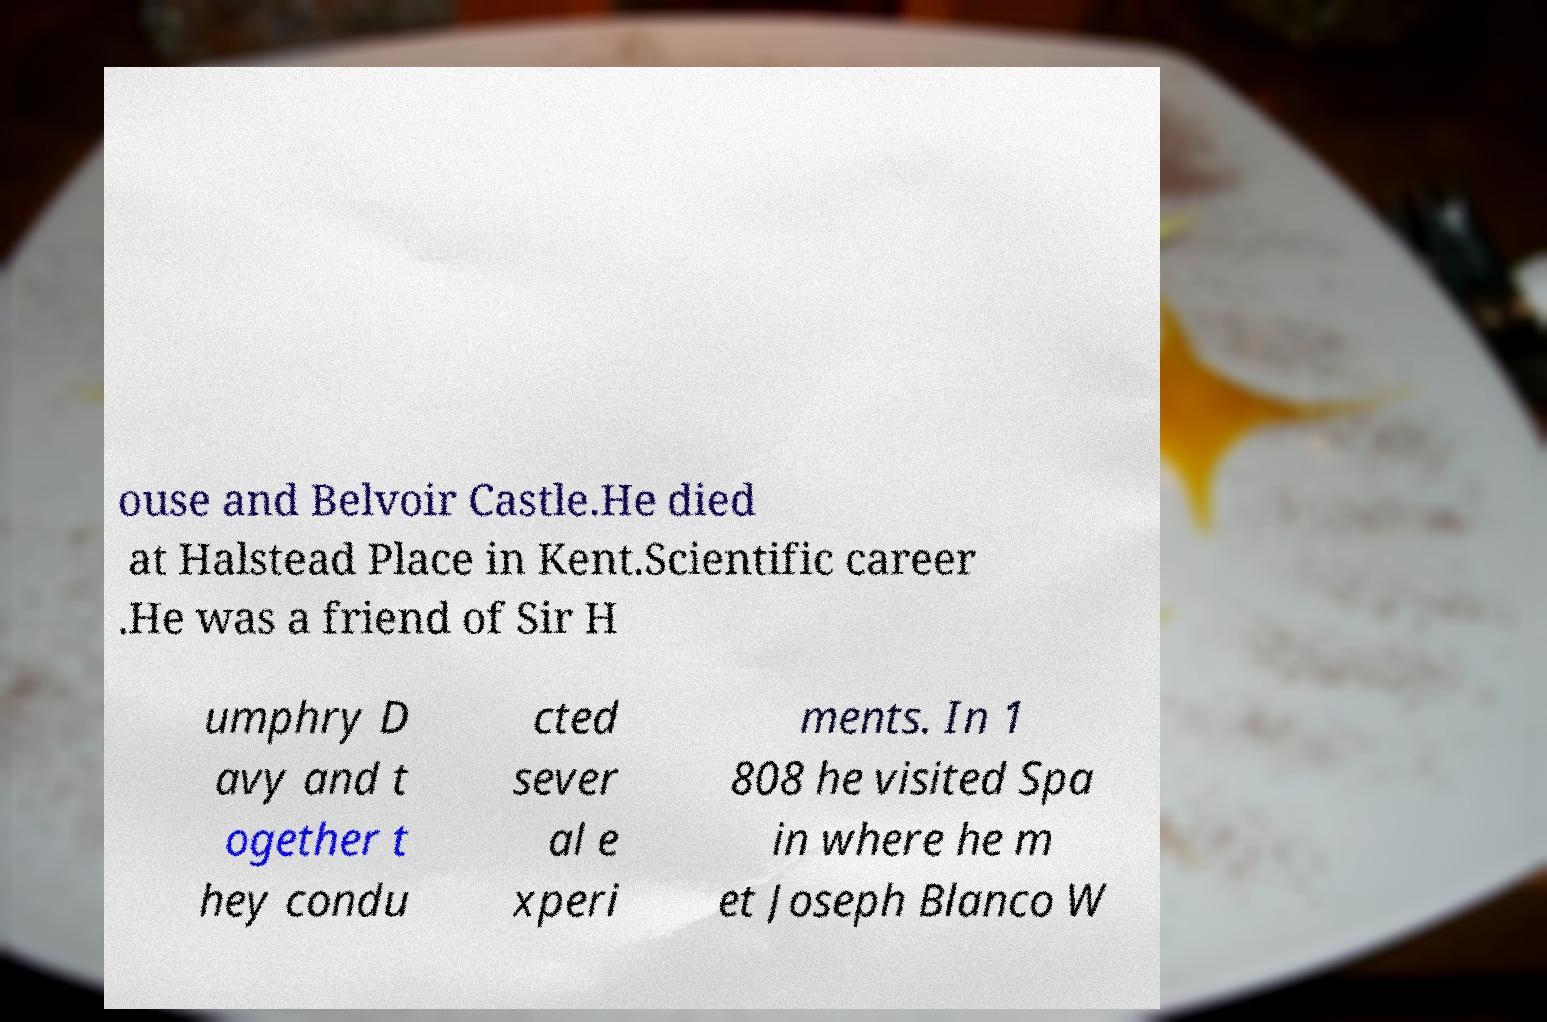What messages or text are displayed in this image? I need them in a readable, typed format. ouse and Belvoir Castle.He died at Halstead Place in Kent.Scientific career .He was a friend of Sir H umphry D avy and t ogether t hey condu cted sever al e xperi ments. In 1 808 he visited Spa in where he m et Joseph Blanco W 